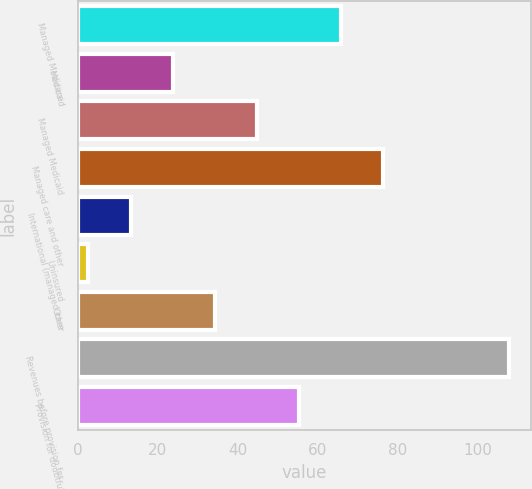<chart> <loc_0><loc_0><loc_500><loc_500><bar_chart><fcel>Managed Medicare<fcel>Medicaid<fcel>Managed Medicaid<fcel>Managed care and other<fcel>International (managed care<fcel>Uninsured<fcel>Other<fcel>Revenues before provision for<fcel>Provision for doubtful<nl><fcel>65.76<fcel>23.72<fcel>44.74<fcel>76.27<fcel>13.21<fcel>2.7<fcel>34.23<fcel>107.8<fcel>55.25<nl></chart> 